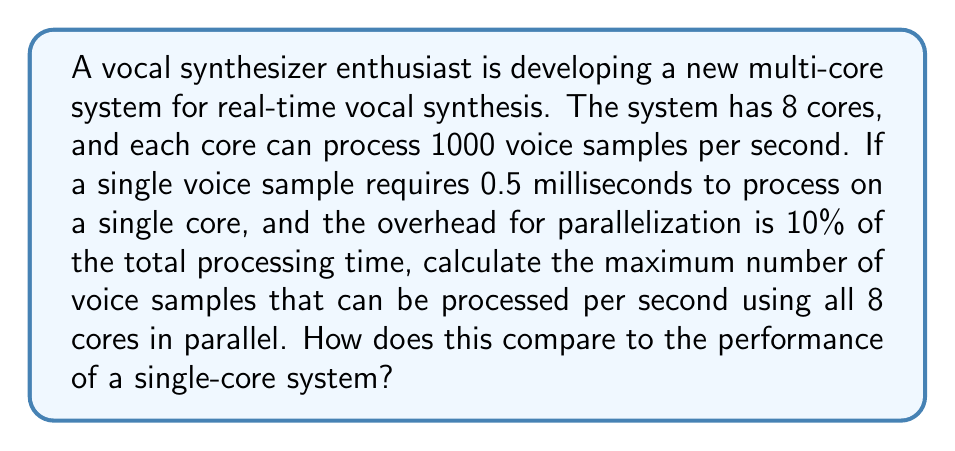Can you answer this question? Let's approach this problem step-by-step:

1. Calculate the processing time for a single sample on one core:
   $$ T_{single} = 0.5 \text{ ms} = 0.0005 \text{ s} $$

2. Calculate the number of samples processed by a single core in one second:
   $$ N_{single} = \frac{1 \text{ s}}{0.0005 \text{ s/sample}} = 2000 \text{ samples} $$

3. For the parallel system, we need to account for the parallelization overhead:
   $$ T_{parallel} = T_{single} + 10\% \cdot T_{single} = 1.1 \cdot T_{single} = 1.1 \cdot 0.0005 \text{ s} = 0.00055 \text{ s} $$

4. Calculate the number of samples processed by all 8 cores in one second:
   $$ N_{parallel} = \frac{8 \text{ cores} \cdot 1 \text{ s}}{0.00055 \text{ s/sample}} = 14,545.45 \text{ samples} $$

5. Round down to the nearest whole number:
   $$ N_{parallel} = 14,545 \text{ samples} $$

6. Compare to single-core performance:
   $$ \text{Speedup} = \frac{N_{parallel}}{N_{single}} = \frac{14,545}{2000} \approx 7.27 $$

This means the 8-core system is about 7.27 times faster than the single-core system, despite the 10% overhead for parallelization.
Answer: The maximum number of voice samples that can be processed per second using all 8 cores in parallel is 14,545 samples. This is approximately 7.27 times faster than a single-core system, which can process 2000 samples per second. 